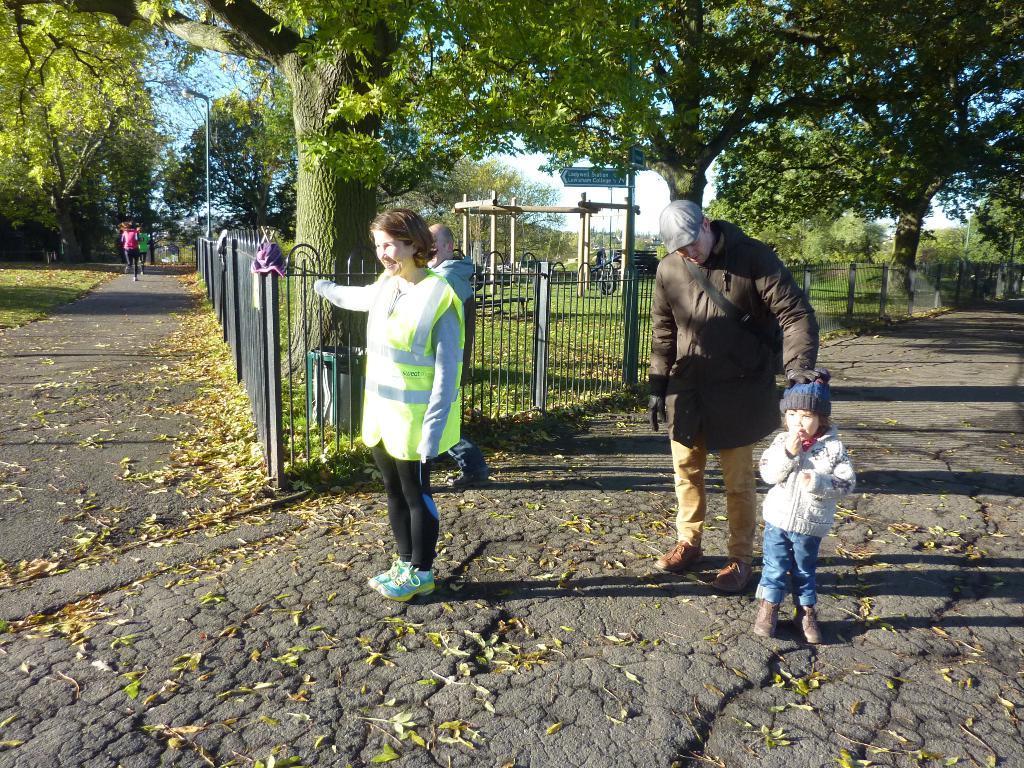Please provide a concise description of this image. In this image we can see some people standing beside the fence. On the left side we can see dried leaves and some people running on a pathway. On the backside we can see some trees, the bark of a tree, a wooden roof, a street sign to a pole, the grass and the sky. 